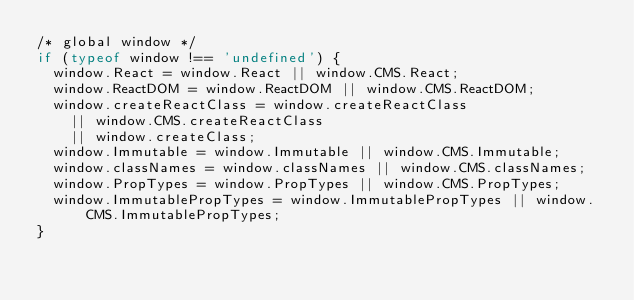Convert code to text. <code><loc_0><loc_0><loc_500><loc_500><_JavaScript_>/* global window */
if (typeof window !== 'undefined') {
  window.React = window.React || window.CMS.React;
  window.ReactDOM = window.ReactDOM || window.CMS.ReactDOM;
  window.createReactClass = window.createReactClass
    || window.CMS.createReactClass
    || window.createClass;
  window.Immutable = window.Immutable || window.CMS.Immutable;
  window.classNames = window.classNames || window.CMS.classNames;
  window.PropTypes = window.PropTypes || window.CMS.PropTypes;
  window.ImmutablePropTypes = window.ImmutablePropTypes || window.CMS.ImmutablePropTypes;
}
</code> 